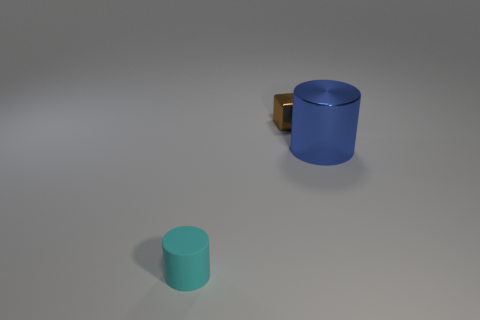Add 1 metallic balls. How many objects exist? 4 Subtract all cylinders. How many objects are left? 1 Subtract 0 green spheres. How many objects are left? 3 Subtract all blue shiny cylinders. Subtract all small brown blocks. How many objects are left? 1 Add 2 cyan things. How many cyan things are left? 3 Add 3 large cylinders. How many large cylinders exist? 4 